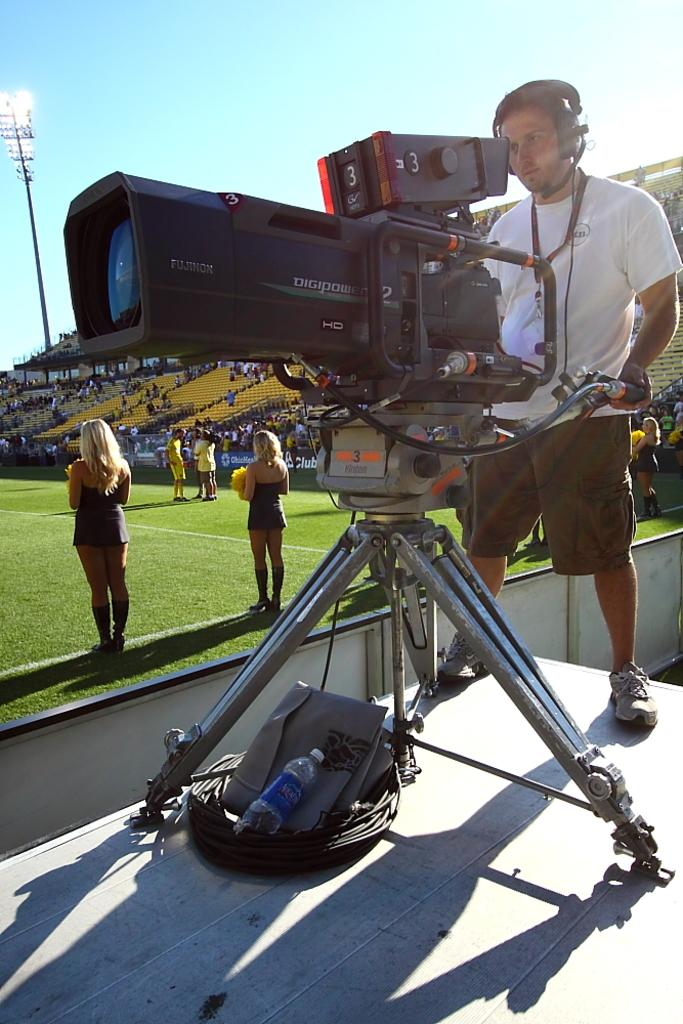Provide a one-sentence caption for the provided image. A man operates a large Digipower camera on the field of a sports game. 